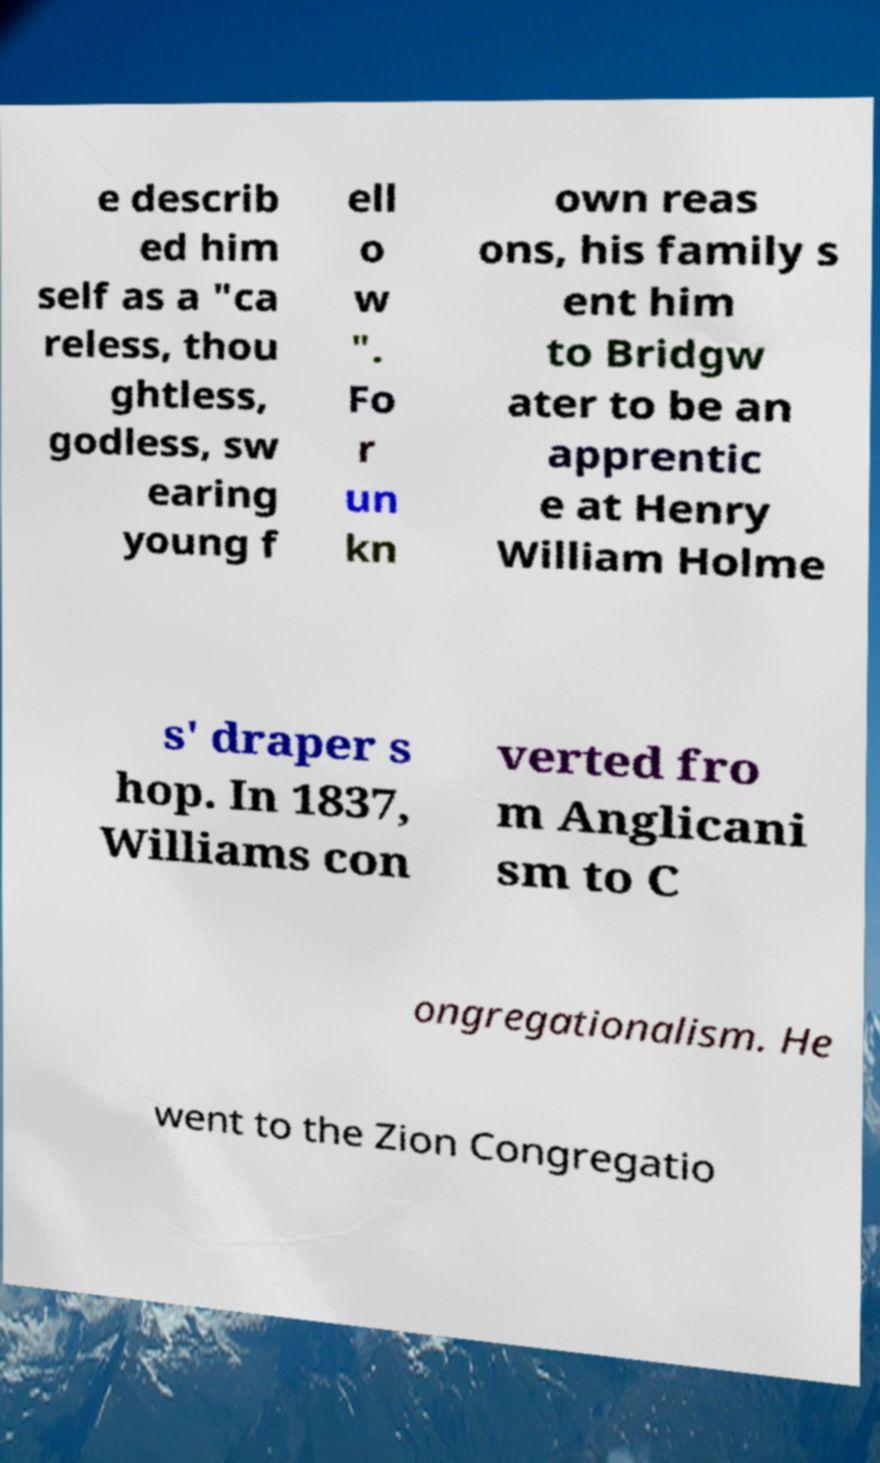I need the written content from this picture converted into text. Can you do that? e describ ed him self as a "ca reless, thou ghtless, godless, sw earing young f ell o w ". Fo r un kn own reas ons, his family s ent him to Bridgw ater to be an apprentic e at Henry William Holme s' draper s hop. In 1837, Williams con verted fro m Anglicani sm to C ongregationalism. He went to the Zion Congregatio 